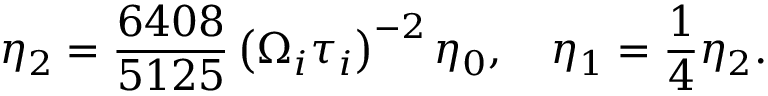<formula> <loc_0><loc_0><loc_500><loc_500>\eta _ { 2 } = \frac { 6 4 0 8 } { 5 1 2 5 } \left ( \Omega _ { i } \tau _ { i } \right ) ^ { - 2 } \eta _ { 0 } , \quad \eta _ { 1 } = \frac { 1 } { 4 } \eta _ { 2 } .</formula> 